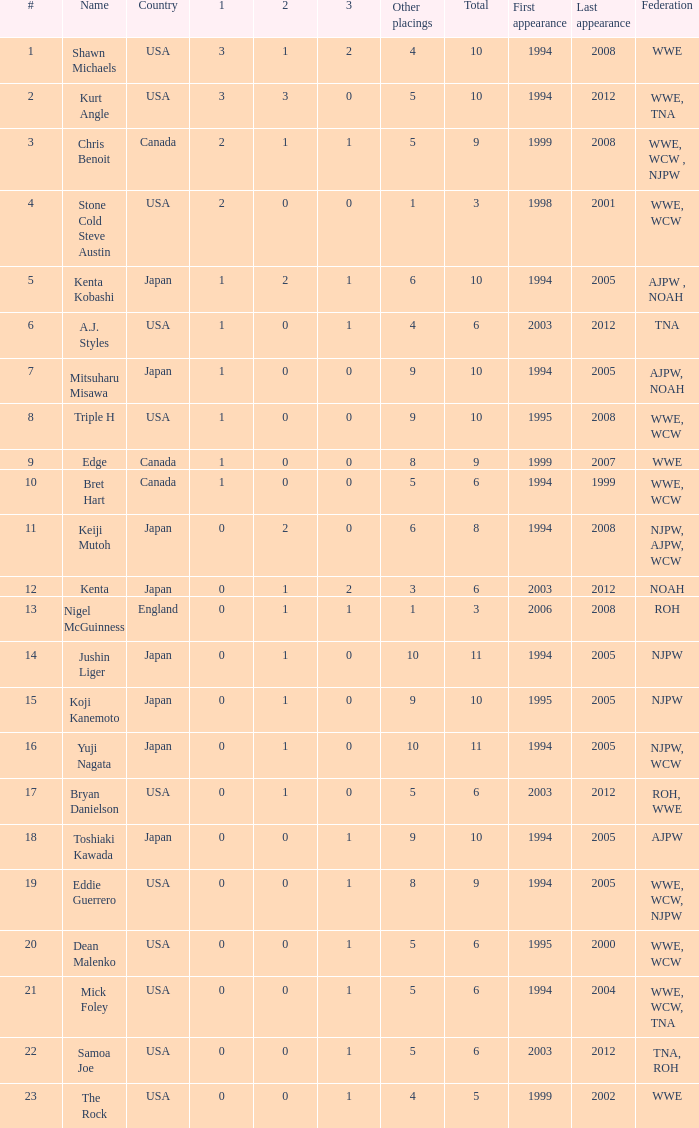How many times has a wrestler whose federation was roh, wwe competed in this event? 1.0. 